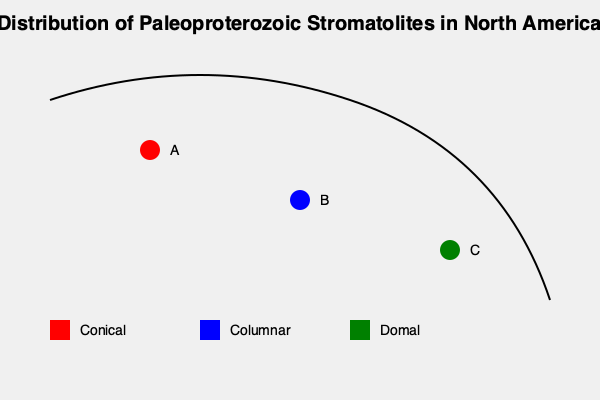Based on the distribution map of Paleoproterozoic stromatolites in North America, which type of stromatolite is most likely to be found in the northernmost location (A), and what does this suggest about the depositional environment in that region during the Paleoproterozoic? To answer this question, we need to analyze the information provided in the map and consider the implications of stromatolite morphology on depositional environments:

1. Observe the map: Location A is the northernmost point and is marked in red.

2. Consult the legend: The red color corresponds to conical stromatolites.

3. Understand stromatolite morphology:
   - Conical stromatolites typically form in shallow marine environments with moderate to high wave energy.
   - They are often found in subtidal to lower intertidal zones.

4. Consider the implications:
   - The presence of conical stromatolites suggests that the northernmost region (A) was likely a shallow marine environment during the Paleoproterozoic.
   - The water depth was probably in the subtidal to lower intertidal range.
   - The area experienced moderate to high wave energy, which shaped the conical form of the stromatolites.

5. Compare with other locations:
   - Location B (blue) indicates columnar stromatolites, which typically form in calmer, deeper waters.
   - Location C (green) shows domal stromatolites, often associated with lower energy, shallow water environments.

6. Draw conclusions about the depositional environment:
   - The northernmost region likely had higher energy conditions compared to the other locations.
   - This suggests a dynamic coastal environment with significant wave action.
   - The area was probably part of a shallow sea or continental shelf during the Paleoproterozoic.
Answer: Conical stromatolites; shallow marine environment with moderate to high wave energy 